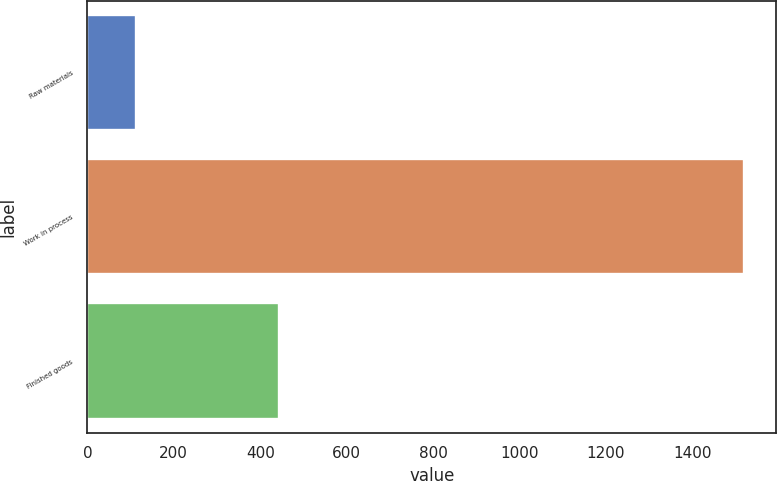Convert chart. <chart><loc_0><loc_0><loc_500><loc_500><bar_chart><fcel>Raw materials<fcel>Work in process<fcel>Finished goods<nl><fcel>112<fcel>1519<fcel>444<nl></chart> 